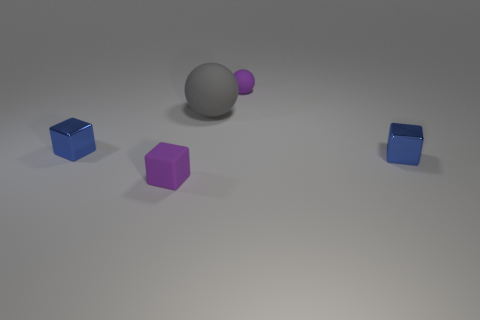Subtract all tiny blue metal blocks. How many blocks are left? 1 Subtract all blue blocks. How many blocks are left? 1 Subtract all spheres. How many objects are left? 3 Subtract 1 blocks. How many blocks are left? 2 Add 5 purple things. How many objects exist? 10 Subtract all cyan blocks. Subtract all gray spheres. How many blocks are left? 3 Subtract all tiny gray rubber cylinders. Subtract all tiny things. How many objects are left? 1 Add 2 gray objects. How many gray objects are left? 3 Add 4 large gray spheres. How many large gray spheres exist? 5 Subtract 0 brown blocks. How many objects are left? 5 